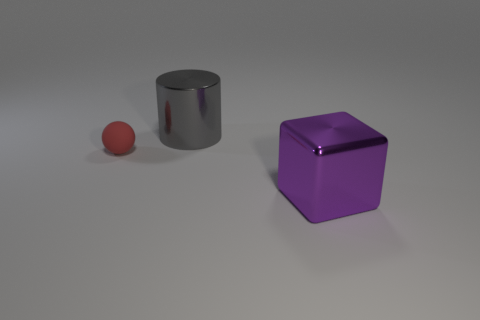What number of gray cylinders are there?
Provide a succinct answer. 1. There is a purple shiny object; is its shape the same as the object that is to the left of the big gray metallic object?
Offer a very short reply. No. There is a thing that is on the right side of the large gray shiny cylinder; what size is it?
Offer a terse response. Large. What is the large purple thing made of?
Provide a succinct answer. Metal. There is a shiny thing in front of the sphere; does it have the same shape as the gray object?
Keep it short and to the point. No. Is there another red metallic block that has the same size as the cube?
Your response must be concise. No. There is a shiny object that is behind the big thing right of the big shiny cylinder; are there any things behind it?
Ensure brevity in your answer.  No. Do the small rubber ball and the large thing that is in front of the big gray metallic cylinder have the same color?
Offer a very short reply. No. What is the material of the thing that is left of the big metal object that is behind the big shiny object in front of the metallic cylinder?
Give a very brief answer. Rubber. There is a large thing that is in front of the big cylinder; what shape is it?
Keep it short and to the point. Cube. 